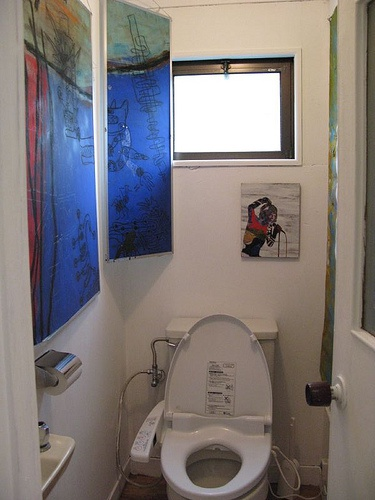Describe the objects in this image and their specific colors. I can see toilet in gray tones and sink in gray, darkgray, and black tones in this image. 